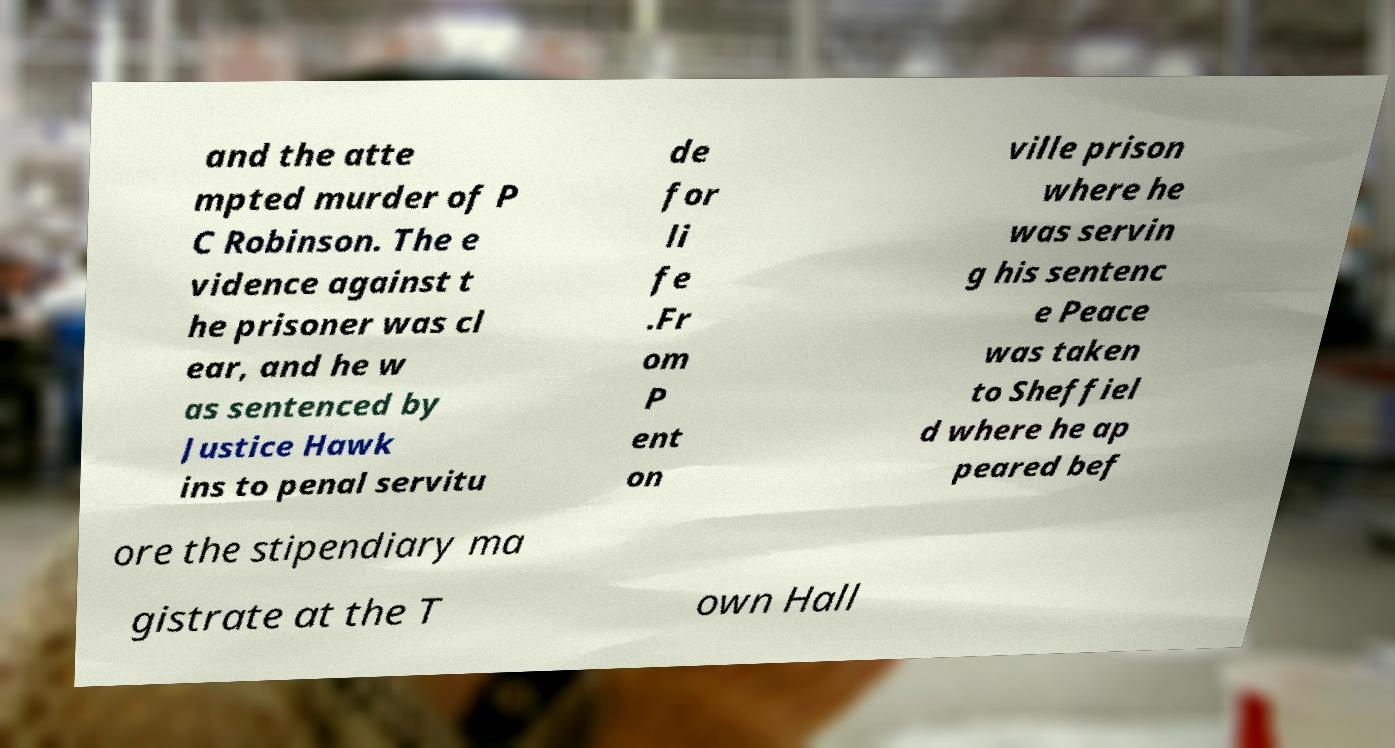What messages or text are displayed in this image? I need them in a readable, typed format. and the atte mpted murder of P C Robinson. The e vidence against t he prisoner was cl ear, and he w as sentenced by Justice Hawk ins to penal servitu de for li fe .Fr om P ent on ville prison where he was servin g his sentenc e Peace was taken to Sheffiel d where he ap peared bef ore the stipendiary ma gistrate at the T own Hall 